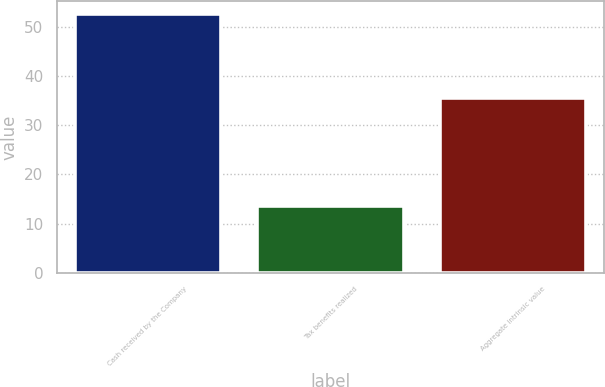<chart> <loc_0><loc_0><loc_500><loc_500><bar_chart><fcel>Cash received by the Company<fcel>Tax benefits realized<fcel>Aggregate intrinsic value<nl><fcel>52.6<fcel>13.6<fcel>35.5<nl></chart> 